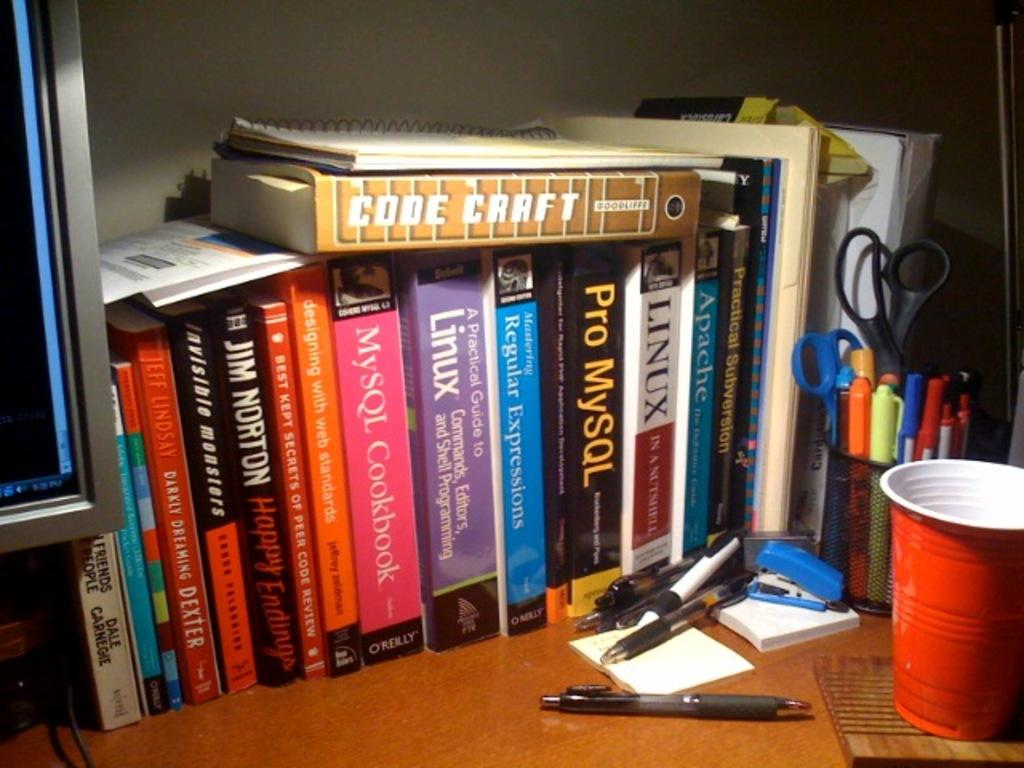<image>
Relay a brief, clear account of the picture shown. A book called Code Craft is laying on top of other books. 